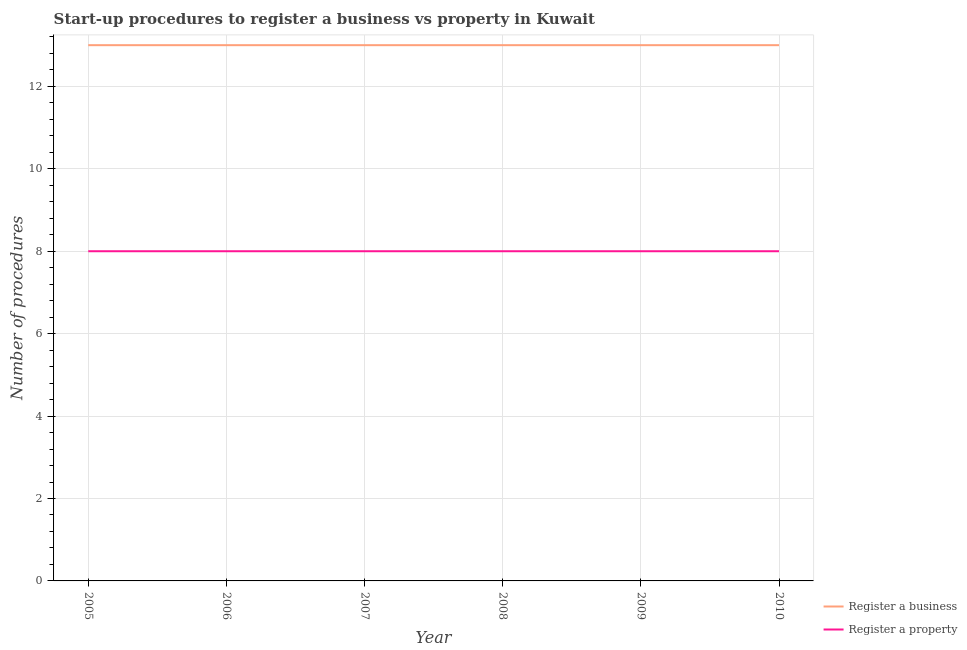How many different coloured lines are there?
Ensure brevity in your answer.  2. Does the line corresponding to number of procedures to register a business intersect with the line corresponding to number of procedures to register a property?
Give a very brief answer. No. What is the number of procedures to register a business in 2010?
Provide a succinct answer. 13. Across all years, what is the maximum number of procedures to register a business?
Your answer should be compact. 13. Across all years, what is the minimum number of procedures to register a property?
Provide a succinct answer. 8. What is the total number of procedures to register a business in the graph?
Give a very brief answer. 78. What is the difference between the number of procedures to register a property in 2005 and that in 2008?
Your response must be concise. 0. What is the difference between the number of procedures to register a property in 2005 and the number of procedures to register a business in 2010?
Make the answer very short. -5. In the year 2005, what is the difference between the number of procedures to register a business and number of procedures to register a property?
Keep it short and to the point. 5. What is the ratio of the number of procedures to register a property in 2006 to that in 2007?
Your response must be concise. 1. Is the number of procedures to register a property in 2005 less than that in 2008?
Keep it short and to the point. No. Is the difference between the number of procedures to register a business in 2005 and 2009 greater than the difference between the number of procedures to register a property in 2005 and 2009?
Offer a very short reply. No. Does the number of procedures to register a business monotonically increase over the years?
Ensure brevity in your answer.  No. Is the number of procedures to register a property strictly greater than the number of procedures to register a business over the years?
Offer a very short reply. No. How many lines are there?
Your answer should be very brief. 2. How many years are there in the graph?
Ensure brevity in your answer.  6. What is the difference between two consecutive major ticks on the Y-axis?
Your response must be concise. 2. Are the values on the major ticks of Y-axis written in scientific E-notation?
Your answer should be very brief. No. Does the graph contain any zero values?
Ensure brevity in your answer.  No. Where does the legend appear in the graph?
Your response must be concise. Bottom right. How many legend labels are there?
Ensure brevity in your answer.  2. What is the title of the graph?
Keep it short and to the point. Start-up procedures to register a business vs property in Kuwait. Does "% of GNI" appear as one of the legend labels in the graph?
Ensure brevity in your answer.  No. What is the label or title of the Y-axis?
Your response must be concise. Number of procedures. What is the Number of procedures of Register a property in 2005?
Keep it short and to the point. 8. What is the Number of procedures in Register a business in 2009?
Keep it short and to the point. 13. What is the Number of procedures in Register a property in 2010?
Make the answer very short. 8. Across all years, what is the maximum Number of procedures in Register a business?
Your answer should be very brief. 13. Across all years, what is the minimum Number of procedures of Register a property?
Provide a succinct answer. 8. What is the difference between the Number of procedures of Register a business in 2005 and that in 2006?
Offer a terse response. 0. What is the difference between the Number of procedures of Register a property in 2005 and that in 2006?
Provide a short and direct response. 0. What is the difference between the Number of procedures in Register a property in 2005 and that in 2008?
Your answer should be very brief. 0. What is the difference between the Number of procedures of Register a business in 2005 and that in 2009?
Your response must be concise. 0. What is the difference between the Number of procedures of Register a business in 2005 and that in 2010?
Your answer should be very brief. 0. What is the difference between the Number of procedures in Register a business in 2006 and that in 2007?
Provide a short and direct response. 0. What is the difference between the Number of procedures of Register a business in 2006 and that in 2008?
Provide a short and direct response. 0. What is the difference between the Number of procedures in Register a property in 2006 and that in 2008?
Provide a succinct answer. 0. What is the difference between the Number of procedures in Register a business in 2006 and that in 2009?
Provide a succinct answer. 0. What is the difference between the Number of procedures in Register a property in 2006 and that in 2009?
Provide a succinct answer. 0. What is the difference between the Number of procedures of Register a property in 2006 and that in 2010?
Provide a short and direct response. 0. What is the difference between the Number of procedures in Register a business in 2007 and that in 2008?
Your answer should be very brief. 0. What is the difference between the Number of procedures of Register a property in 2007 and that in 2008?
Offer a very short reply. 0. What is the difference between the Number of procedures in Register a business in 2007 and that in 2009?
Offer a very short reply. 0. What is the difference between the Number of procedures in Register a property in 2007 and that in 2009?
Ensure brevity in your answer.  0. What is the difference between the Number of procedures of Register a business in 2007 and that in 2010?
Make the answer very short. 0. What is the difference between the Number of procedures of Register a business in 2008 and that in 2010?
Your answer should be very brief. 0. What is the difference between the Number of procedures of Register a property in 2008 and that in 2010?
Give a very brief answer. 0. What is the difference between the Number of procedures of Register a property in 2009 and that in 2010?
Provide a short and direct response. 0. What is the difference between the Number of procedures in Register a business in 2005 and the Number of procedures in Register a property in 2006?
Give a very brief answer. 5. What is the difference between the Number of procedures in Register a business in 2005 and the Number of procedures in Register a property in 2007?
Your answer should be very brief. 5. What is the difference between the Number of procedures in Register a business in 2005 and the Number of procedures in Register a property in 2008?
Your answer should be very brief. 5. What is the difference between the Number of procedures of Register a business in 2005 and the Number of procedures of Register a property in 2009?
Your answer should be very brief. 5. What is the difference between the Number of procedures of Register a business in 2006 and the Number of procedures of Register a property in 2008?
Provide a succinct answer. 5. What is the difference between the Number of procedures of Register a business in 2006 and the Number of procedures of Register a property in 2010?
Make the answer very short. 5. What is the difference between the Number of procedures of Register a business in 2007 and the Number of procedures of Register a property in 2008?
Give a very brief answer. 5. What is the difference between the Number of procedures of Register a business in 2008 and the Number of procedures of Register a property in 2009?
Offer a terse response. 5. What is the difference between the Number of procedures in Register a business in 2009 and the Number of procedures in Register a property in 2010?
Provide a short and direct response. 5. What is the average Number of procedures in Register a business per year?
Offer a very short reply. 13. In the year 2007, what is the difference between the Number of procedures of Register a business and Number of procedures of Register a property?
Provide a short and direct response. 5. In the year 2010, what is the difference between the Number of procedures of Register a business and Number of procedures of Register a property?
Your response must be concise. 5. What is the ratio of the Number of procedures in Register a business in 2005 to that in 2006?
Provide a short and direct response. 1. What is the ratio of the Number of procedures of Register a property in 2005 to that in 2007?
Offer a very short reply. 1. What is the ratio of the Number of procedures in Register a business in 2005 to that in 2009?
Offer a very short reply. 1. What is the ratio of the Number of procedures of Register a property in 2005 to that in 2009?
Your response must be concise. 1. What is the ratio of the Number of procedures in Register a property in 2005 to that in 2010?
Your answer should be compact. 1. What is the ratio of the Number of procedures in Register a property in 2006 to that in 2007?
Keep it short and to the point. 1. What is the ratio of the Number of procedures of Register a property in 2006 to that in 2010?
Make the answer very short. 1. What is the ratio of the Number of procedures of Register a business in 2007 to that in 2008?
Your answer should be very brief. 1. What is the ratio of the Number of procedures in Register a property in 2007 to that in 2009?
Offer a terse response. 1. What is the ratio of the Number of procedures of Register a business in 2009 to that in 2010?
Make the answer very short. 1. What is the difference between the highest and the second highest Number of procedures of Register a property?
Give a very brief answer. 0. 